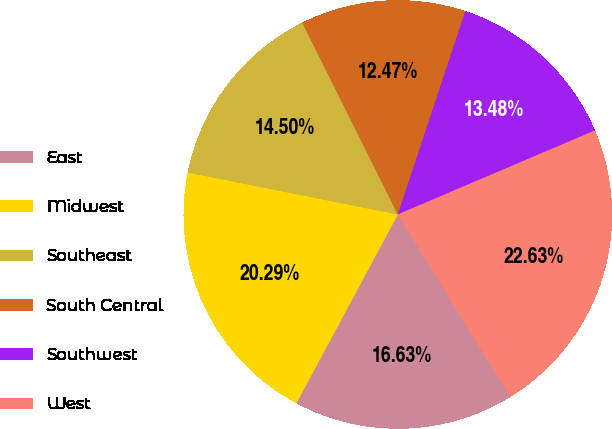Convert chart. <chart><loc_0><loc_0><loc_500><loc_500><pie_chart><fcel>East<fcel>Midwest<fcel>Southeast<fcel>South Central<fcel>Southwest<fcel>West<nl><fcel>16.63%<fcel>20.29%<fcel>14.5%<fcel>12.47%<fcel>13.48%<fcel>22.63%<nl></chart> 